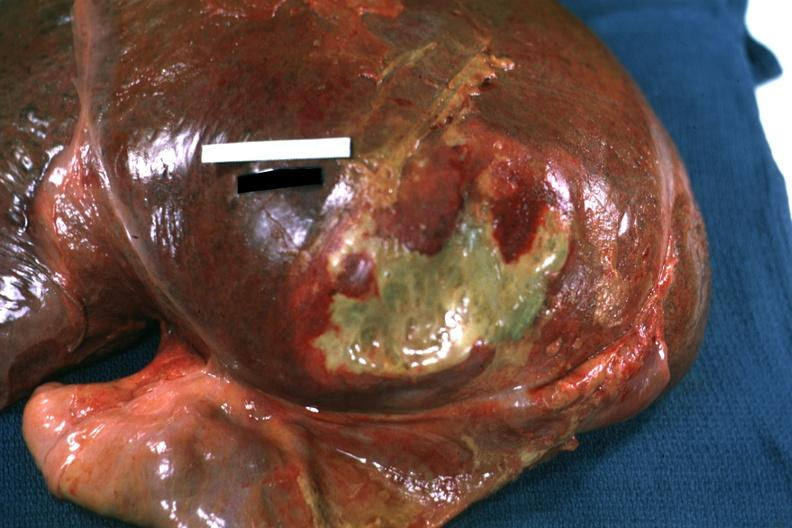how is right leaf of diaphragm reflected to show flat mass of yellow pus quite good example?
Answer the question using a single word or phrase. Green 